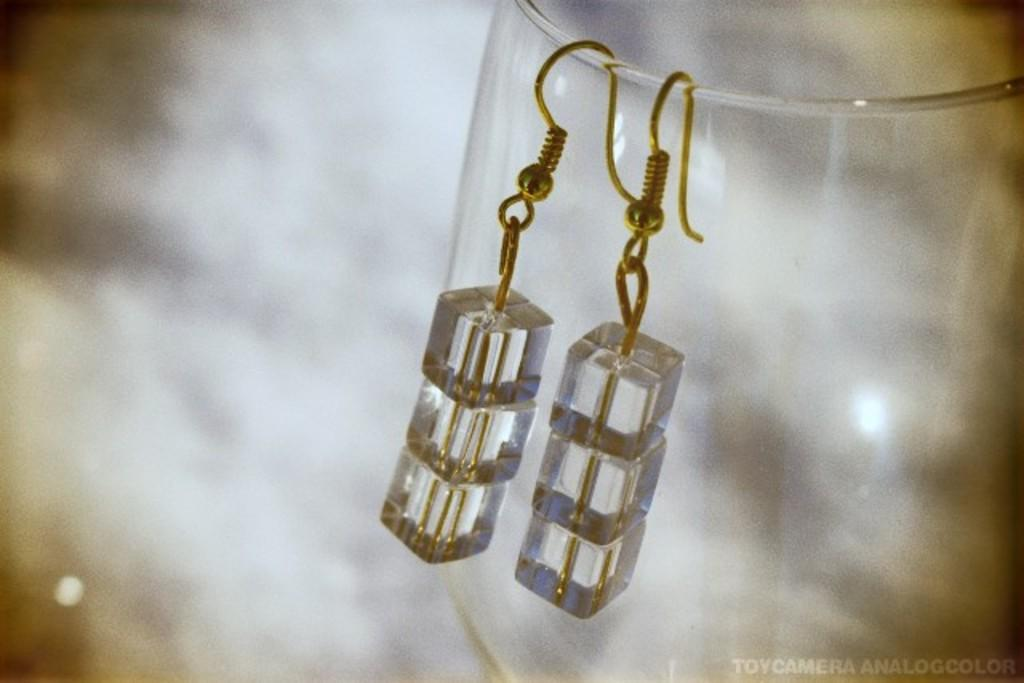What object is present in the image that can hold liquid? There is a glass in the image. What is hanging on the glass in the image? Earrings are hanged on the glass. How would you describe the background of the image? The background of the image is blurred. Where can you find text or writing in the image? The text or writing is located in the right bottom corner of the image. What type of cracker is being played on the guitar in the image? There is no guitar or cracker present in the image. What sign can be seen in the image? There is no sign present in the image. 